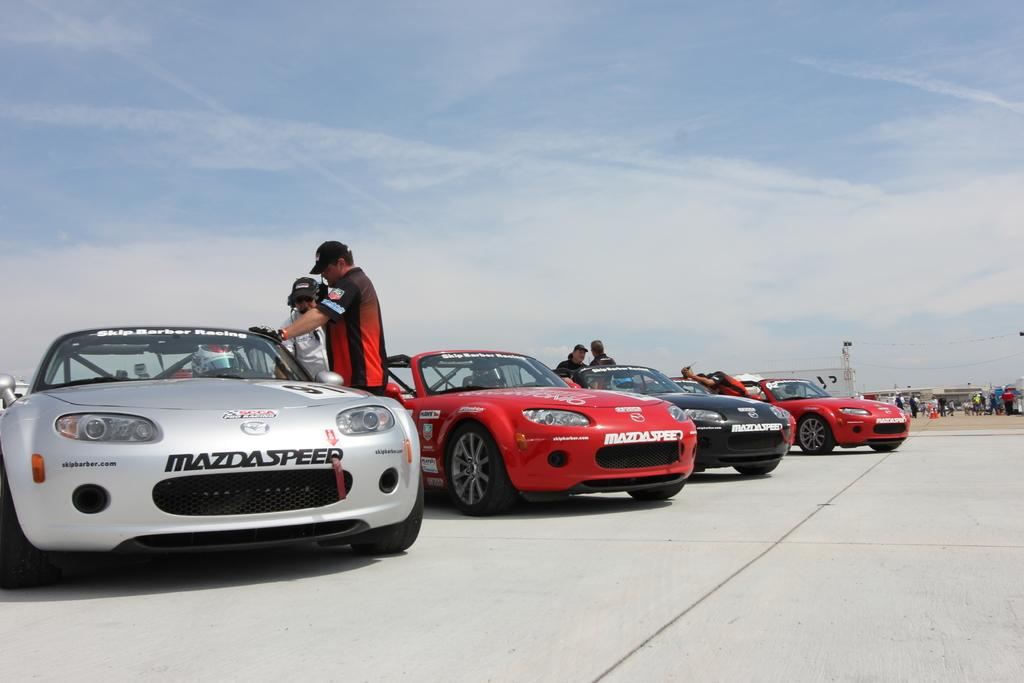How many sports cars are in the image? There are four sports cars in the image. What is the status of the sports cars in the image? The sports cars are parked. Are there any people present in the image? Yes, there are people standing in the image. What can be seen in the background of the image? There is a building visible in the background of the image. What type of servant is standing next to the sports cars in the image? There is no servant present in the image; only people are visible. 